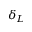<formula> <loc_0><loc_0><loc_500><loc_500>\delta _ { L }</formula> 